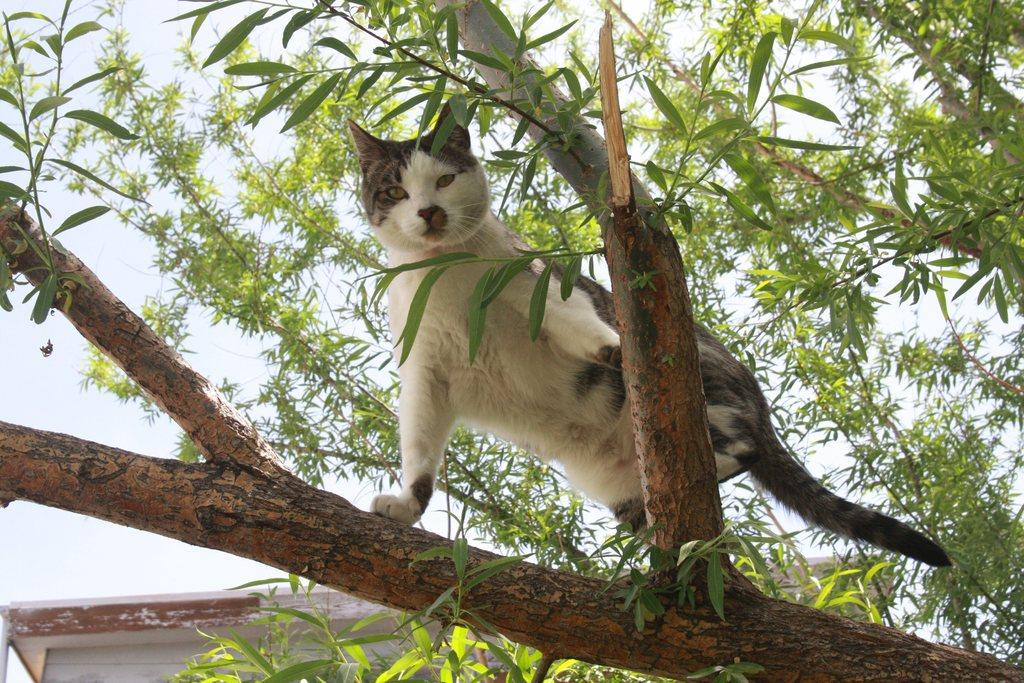What is the main object or feature in the image? There is a tree in the image. Can you describe the cat in the image? A white and grey cat is standing on a branch of the tree. What can be seen in the background of the image? There is a white color thing in the background of the image. How many elbows can be seen on the cat in the image? Cats do not have elbows like humans, so there are no elbows visible on the cat in the image. Are there any boys playing near the tree in the image? The provided facts do not mention any boys or their activities in the image, so we cannot confirm their presence. 